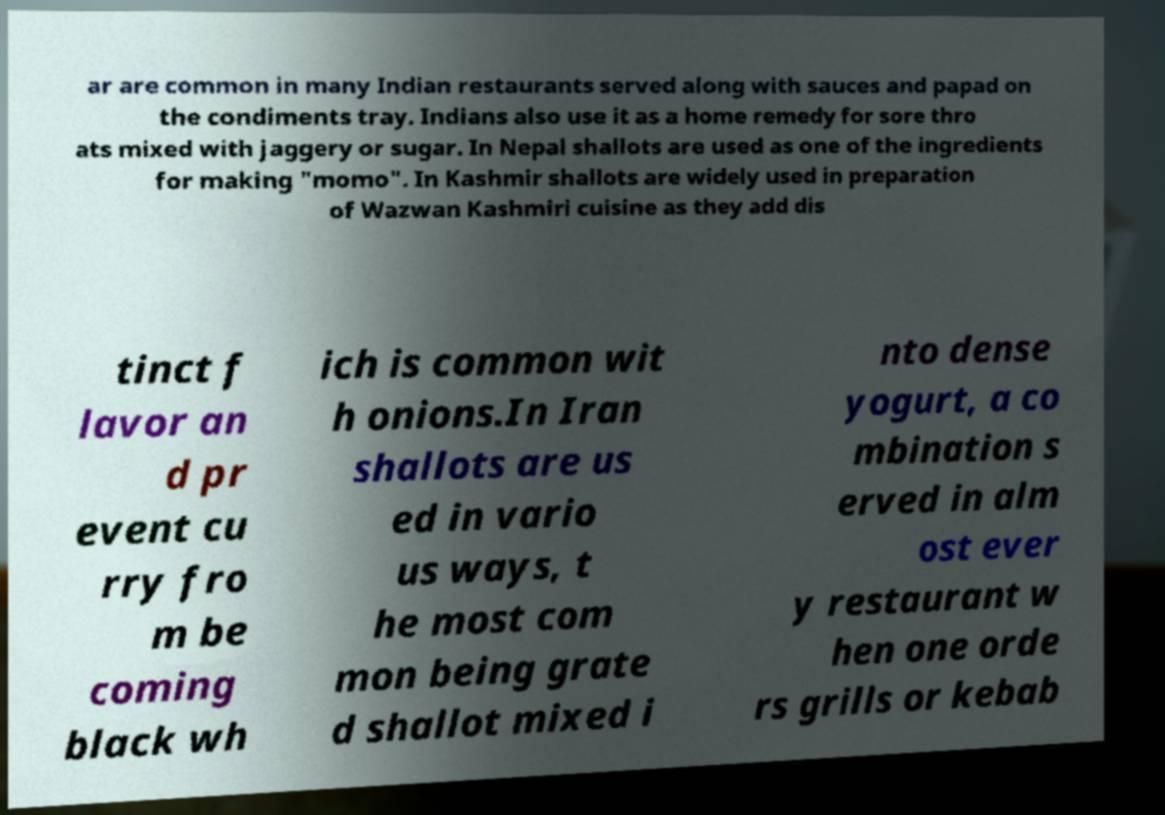Could you assist in decoding the text presented in this image and type it out clearly? ar are common in many Indian restaurants served along with sauces and papad on the condiments tray. Indians also use it as a home remedy for sore thro ats mixed with jaggery or sugar. In Nepal shallots are used as one of the ingredients for making "momo". In Kashmir shallots are widely used in preparation of Wazwan Kashmiri cuisine as they add dis tinct f lavor an d pr event cu rry fro m be coming black wh ich is common wit h onions.In Iran shallots are us ed in vario us ways, t he most com mon being grate d shallot mixed i nto dense yogurt, a co mbination s erved in alm ost ever y restaurant w hen one orde rs grills or kebab 